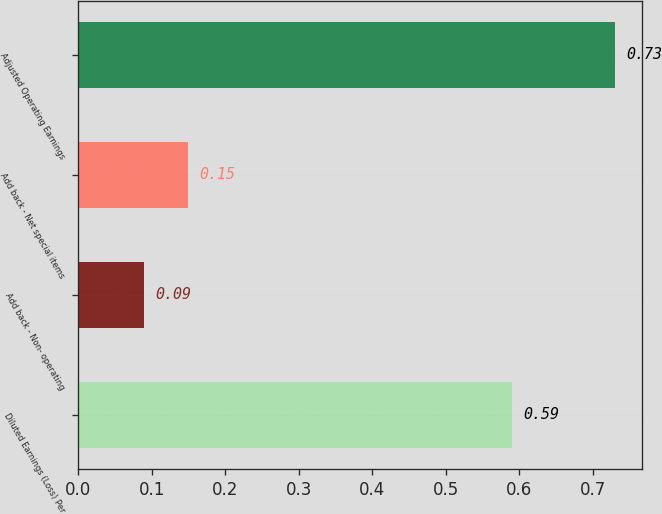<chart> <loc_0><loc_0><loc_500><loc_500><bar_chart><fcel>Diluted Earnings (Loss) Per<fcel>Add back - Non- operating<fcel>Add back - Net special items<fcel>Adjusted Operating Earnings<nl><fcel>0.59<fcel>0.09<fcel>0.15<fcel>0.73<nl></chart> 